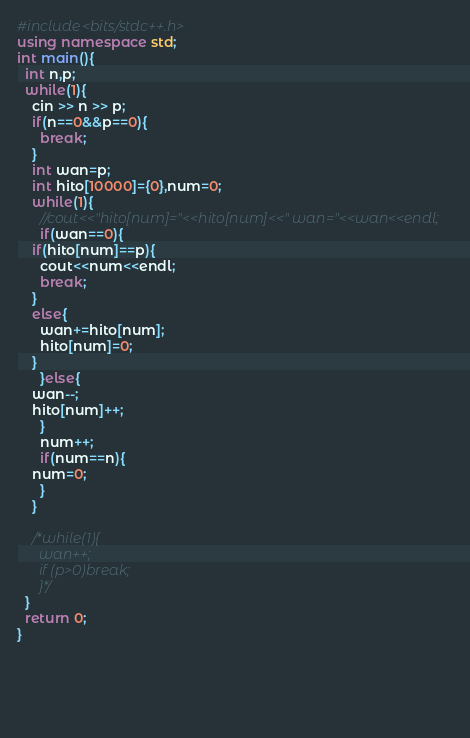Convert code to text. <code><loc_0><loc_0><loc_500><loc_500><_C++_>#include<bits/stdc++.h>
using namespace std;
int main(){
  int n,p;
  while(1){
    cin >> n >> p;
    if(n==0&&p==0){
      break;
    }
    int wan=p;
    int hito[10000]={0},num=0;
    while(1){
      //cout<<"hito[num]="<<hito[num]<<" wan="<<wan<<endl;
      if(wan==0){
	if(hito[num]==p){
	  cout<<num<<endl;
	  break;
	}
	else{
	  wan+=hito[num];
	  hito[num]=0;
	}
      }else{
	wan--;
	hito[num]++;
      }
      num++;
      if(num==n){
	num=0;
      }
    }

    /*while(1){
      wan++;
      if (p>0)break;
      }*/
  }
  return 0;
}
  
 
    
    
  

</code> 